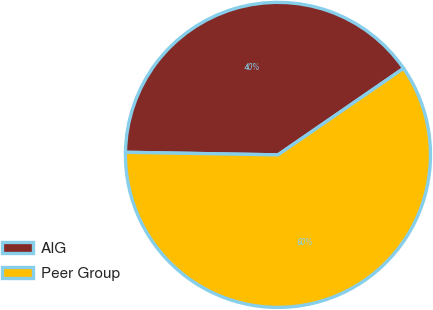<chart> <loc_0><loc_0><loc_500><loc_500><pie_chart><fcel>AIG<fcel>Peer Group<nl><fcel>40.13%<fcel>59.87%<nl></chart> 